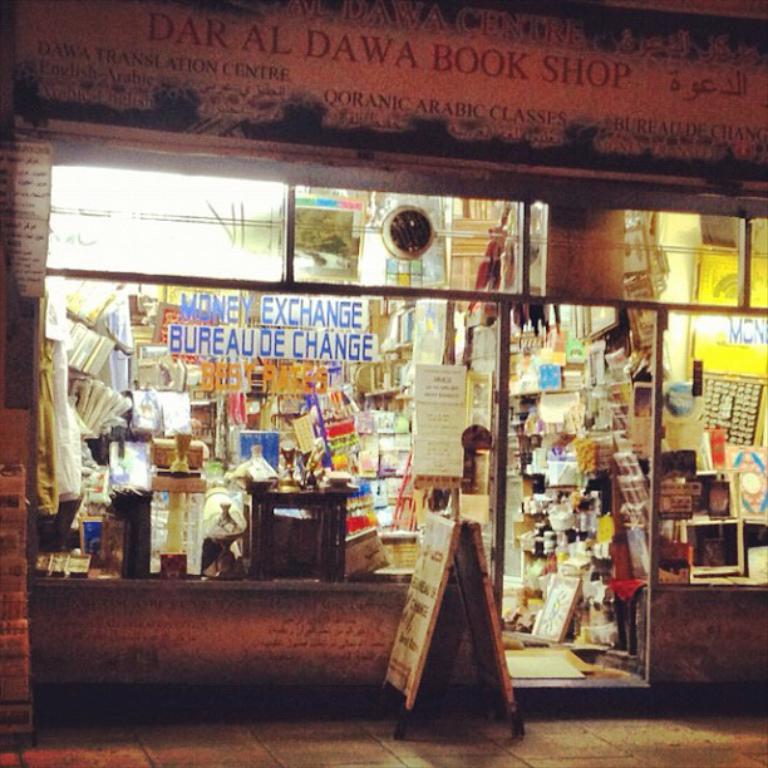What does this shop sell?
Keep it short and to the point. Books. What is the name of the book shop?
Make the answer very short. Dar al dawa. 